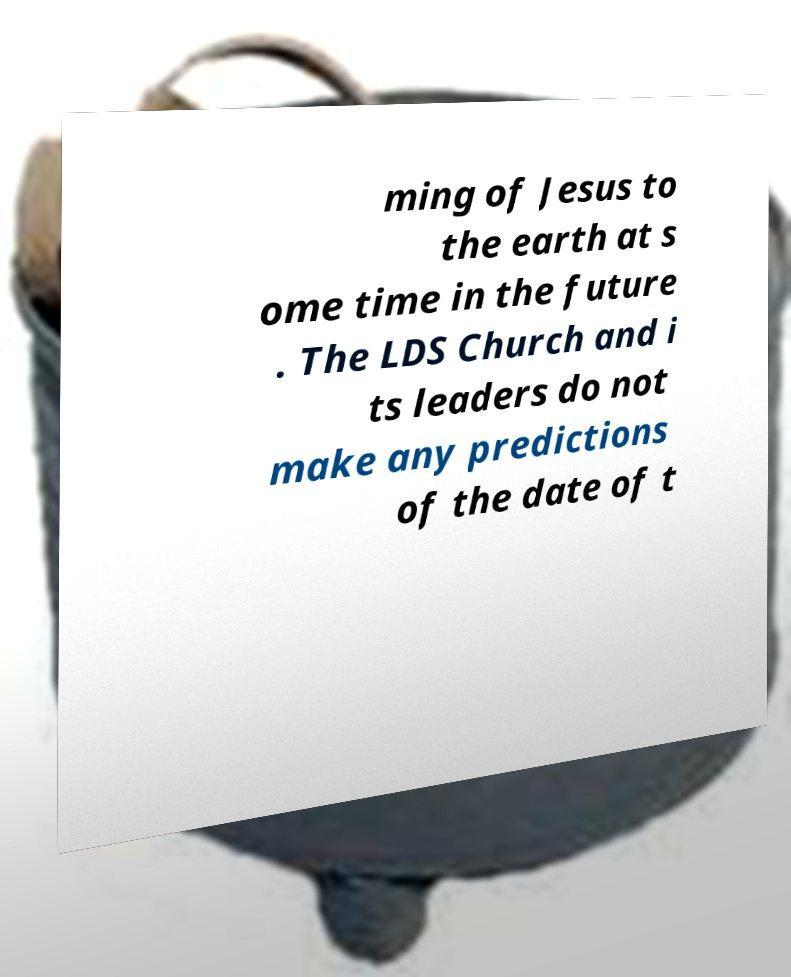Please read and relay the text visible in this image. What does it say? ming of Jesus to the earth at s ome time in the future . The LDS Church and i ts leaders do not make any predictions of the date of t 